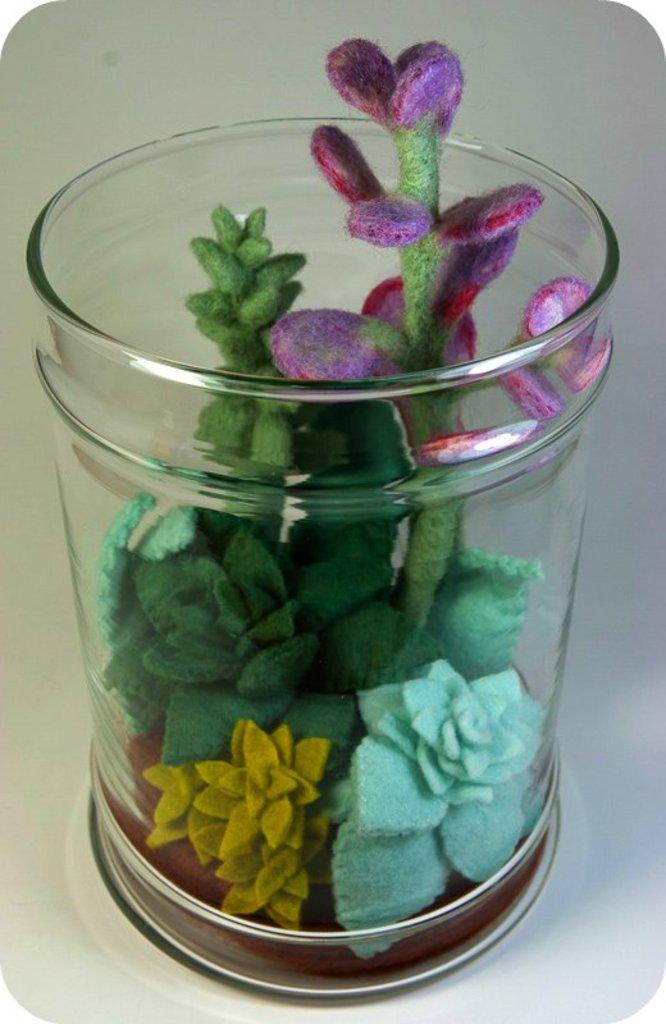What is the main object in the image? There is an artificial flower vase in the image. What is the color of the surface on which the vase is placed? The artificial flower vase is on a white surface. Where is the artificial flower vase located in the image? The artificial flower vase is in the foreground of the image. How many ants can be seen crawling on the book in the image? There is no book or ants present in the image; it features an artificial flower vase on a white surface. 